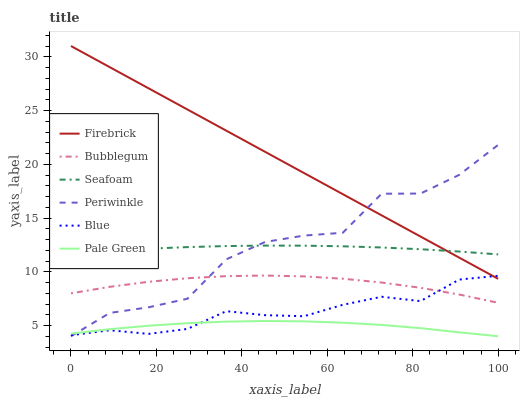Does Pale Green have the minimum area under the curve?
Answer yes or no. Yes. Does Firebrick have the maximum area under the curve?
Answer yes or no. Yes. Does Seafoam have the minimum area under the curve?
Answer yes or no. No. Does Seafoam have the maximum area under the curve?
Answer yes or no. No. Is Firebrick the smoothest?
Answer yes or no. Yes. Is Periwinkle the roughest?
Answer yes or no. Yes. Is Seafoam the smoothest?
Answer yes or no. No. Is Seafoam the roughest?
Answer yes or no. No. Does Pale Green have the lowest value?
Answer yes or no. Yes. Does Firebrick have the lowest value?
Answer yes or no. No. Does Firebrick have the highest value?
Answer yes or no. Yes. Does Seafoam have the highest value?
Answer yes or no. No. Is Bubblegum less than Firebrick?
Answer yes or no. Yes. Is Firebrick greater than Pale Green?
Answer yes or no. Yes. Does Blue intersect Periwinkle?
Answer yes or no. Yes. Is Blue less than Periwinkle?
Answer yes or no. No. Is Blue greater than Periwinkle?
Answer yes or no. No. Does Bubblegum intersect Firebrick?
Answer yes or no. No. 